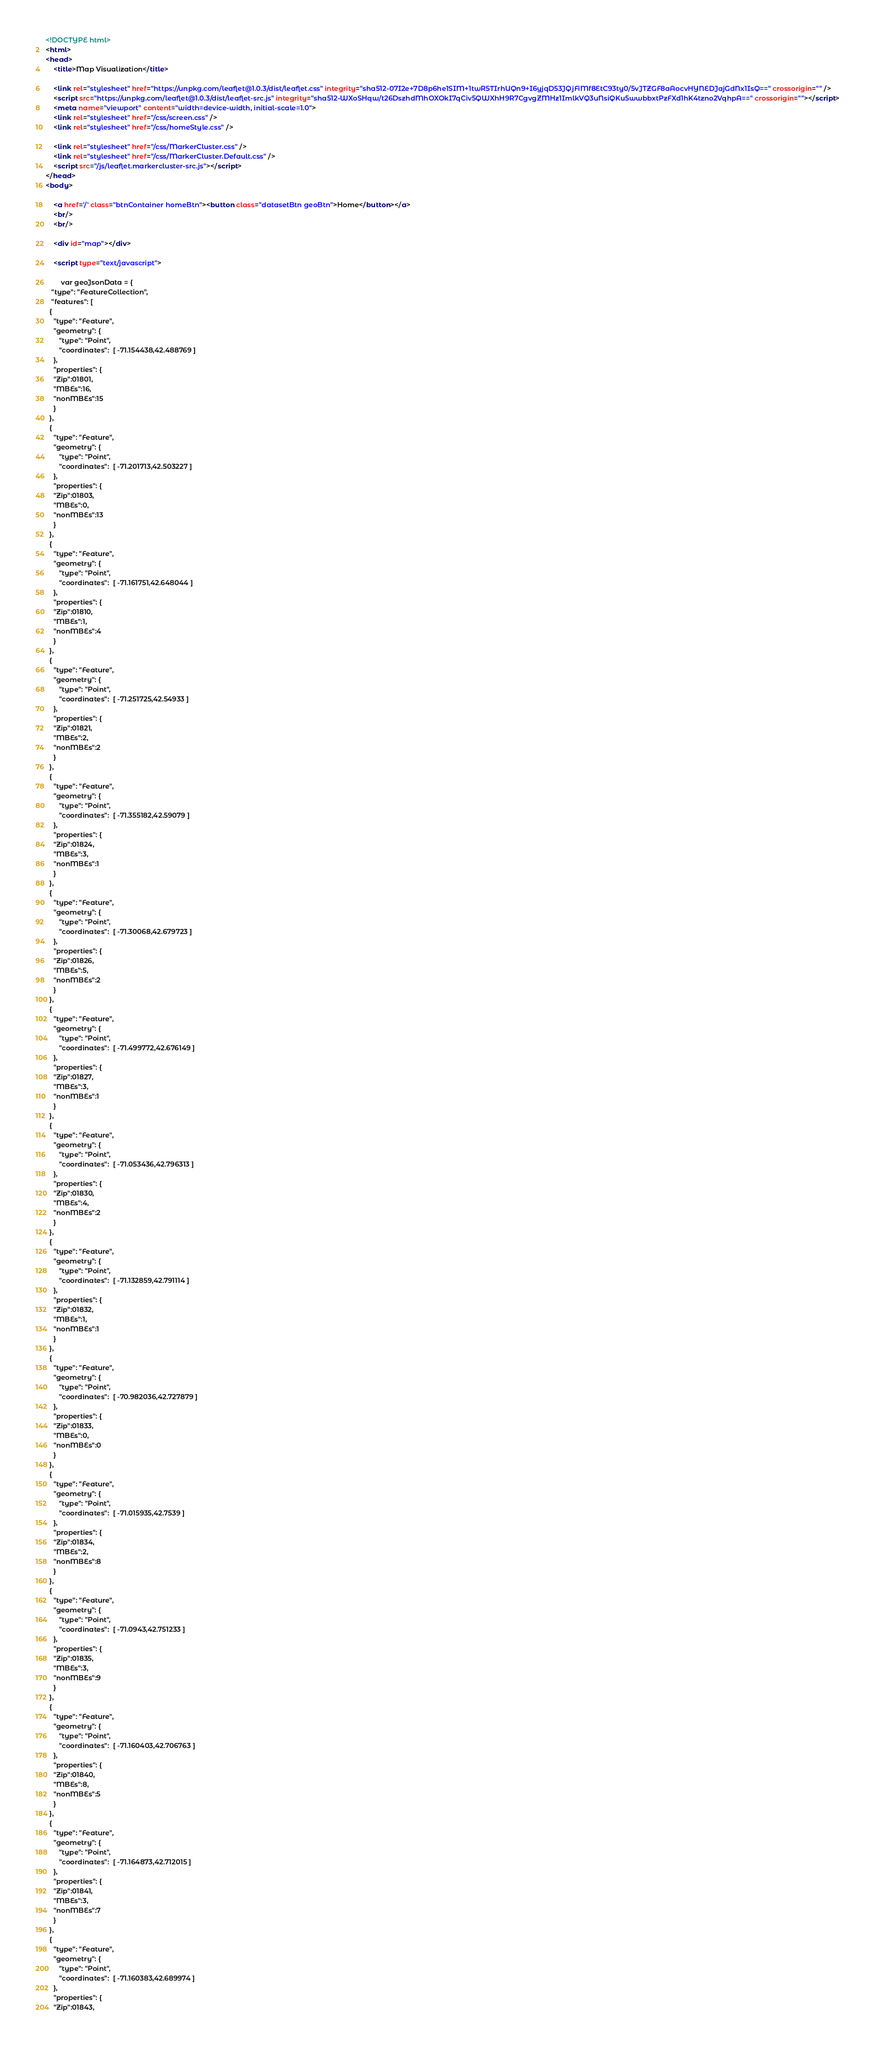<code> <loc_0><loc_0><loc_500><loc_500><_HTML_><!DOCTYPE html>
<html>
<head>
	<title>Map Visualization</title>

	<link rel="stylesheet" href="https://unpkg.com/leaflet@1.0.3/dist/leaflet.css" integrity="sha512-07I2e+7D8p6he1SIM+1twR5TIrhUQn9+I6yjqD53JQjFiMf8EtC93ty0/5vJTZGF8aAocvHYNEDJajGdNx1IsQ==" crossorigin="" />
	<script src="https://unpkg.com/leaflet@1.0.3/dist/leaflet-src.js" integrity="sha512-WXoSHqw/t26DszhdMhOXOkI7qCiv5QWXhH9R7CgvgZMHz1ImlkVQ3uNsiQKu5wwbbxtPzFXd1hK4tzno2VqhpA==" crossorigin=""></script>
	<meta name="viewport" content="width=device-width, initial-scale=1.0">
	<link rel="stylesheet" href="/css/screen.css" />
	<link rel="stylesheet" href="/css/homeStyle.css" />

	<link rel="stylesheet" href="/css/MarkerCluster.css" />
	<link rel="stylesheet" href="/css/MarkerCluster.Default.css" />
	<script src="/js/leaflet.markercluster-src.js"></script>
</head>
<body>

	<a href='/' class="btnContainer homeBtn"><button class="datasetBtn geoBtn">Home</button></a>
	<br/>
	<br/>

	<div id="map"></div>

	<script type="text/javascript">

		var geoJsonData = {
   "type": "FeatureCollection",
   "features": [
  {
    "type": "Feature",
    "geometry": {
       "type": "Point",
       "coordinates":  [ -71.154438,42.488769 ]
    },
    "properties": {
    "Zip":01801,
    "MBEs":16,
    "nonMBEs":15
    }
  },
  {
    "type": "Feature",
    "geometry": {
       "type": "Point",
       "coordinates":  [ -71.201713,42.503227 ]
    },
    "properties": {
    "Zip":01803,
    "MBEs":0,
    "nonMBEs":13
    }
  },
  {
    "type": "Feature",
    "geometry": {
       "type": "Point",
       "coordinates":  [ -71.161751,42.648044 ]
    },
    "properties": {
    "Zip":01810,
    "MBEs":1,
    "nonMBEs":4
    }
  },
  {
    "type": "Feature",
    "geometry": {
       "type": "Point",
       "coordinates":  [ -71.251725,42.54933 ]
    },
    "properties": {
    "Zip":01821,
    "MBEs":2,
    "nonMBEs":2
    }
  },
  {
    "type": "Feature",
    "geometry": {
       "type": "Point",
       "coordinates":  [ -71.355182,42.59079 ]
    },
    "properties": {
    "Zip":01824,
    "MBEs":3,
    "nonMBEs":1
    }
  },
  {
    "type": "Feature",
    "geometry": {
       "type": "Point",
       "coordinates":  [ -71.30068,42.679723 ]
    },
    "properties": {
    "Zip":01826,
    "MBEs":5,
    "nonMBEs":2
    }
  },
  {
    "type": "Feature",
    "geometry": {
       "type": "Point",
       "coordinates":  [ -71.499772,42.676149 ]
    },
    "properties": {
    "Zip":01827,
    "MBEs":3,
    "nonMBEs":1
    }
  },
  {
    "type": "Feature",
    "geometry": {
       "type": "Point",
       "coordinates":  [ -71.053436,42.796313 ]
    },
    "properties": {
    "Zip":01830,
    "MBEs":4,
    "nonMBEs":2
    }
  },
  {
    "type": "Feature",
    "geometry": {
       "type": "Point",
       "coordinates":  [ -71.132859,42.791114 ]
    },
    "properties": {
    "Zip":01832,
    "MBEs":1,
    "nonMBEs":1
    }
  },
  {
    "type": "Feature",
    "geometry": {
       "type": "Point",
       "coordinates":  [ -70.982036,42.727879 ]
    },
    "properties": {
    "Zip":01833,
    "MBEs":0,
    "nonMBEs":0
    }
  },
  {
    "type": "Feature",
    "geometry": {
       "type": "Point",
       "coordinates":  [ -71.015935,42.7539 ]
    },
    "properties": {
    "Zip":01834,
    "MBEs":2,
    "nonMBEs":8
    }
  },
  {
    "type": "Feature",
    "geometry": {
       "type": "Point",
       "coordinates":  [ -71.0943,42.751233 ]
    },
    "properties": {
    "Zip":01835,
    "MBEs":3,
    "nonMBEs":9
    }
  },
  {
    "type": "Feature",
    "geometry": {
       "type": "Point",
       "coordinates":  [ -71.160403,42.706763 ]
    },
    "properties": {
    "Zip":01840,
    "MBEs":8,
    "nonMBEs":5
    }
  },
  {
    "type": "Feature",
    "geometry": {
       "type": "Point",
       "coordinates":  [ -71.164873,42.712015 ]
    },
    "properties": {
    "Zip":01841,
    "MBEs":3,
    "nonMBEs":7
    }
  },
  {
    "type": "Feature",
    "geometry": {
       "type": "Point",
       "coordinates":  [ -71.160383,42.689974 ]
    },
    "properties": {
    "Zip":01843,</code> 